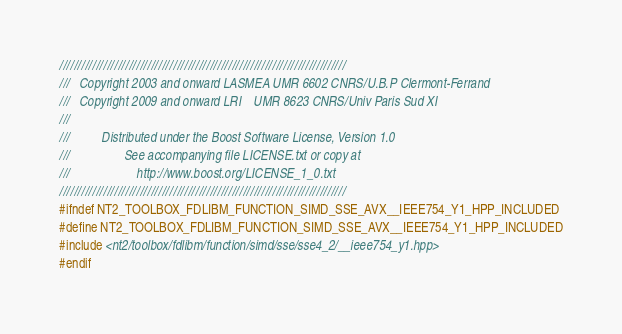Convert code to text. <code><loc_0><loc_0><loc_500><loc_500><_C++_>//////////////////////////////////////////////////////////////////////////////
///   Copyright 2003 and onward LASMEA UMR 6602 CNRS/U.B.P Clermont-Ferrand
///   Copyright 2009 and onward LRI    UMR 8623 CNRS/Univ Paris Sud XI
///
///          Distributed under the Boost Software License, Version 1.0
///                 See accompanying file LICENSE.txt or copy at
///                     http://www.boost.org/LICENSE_1_0.txt
//////////////////////////////////////////////////////////////////////////////
#ifndef NT2_TOOLBOX_FDLIBM_FUNCTION_SIMD_SSE_AVX__IEEE754_Y1_HPP_INCLUDED
#define NT2_TOOLBOX_FDLIBM_FUNCTION_SIMD_SSE_AVX__IEEE754_Y1_HPP_INCLUDED
#include <nt2/toolbox/fdlibm/function/simd/sse/sse4_2/__ieee754_y1.hpp>
#endif
</code> 